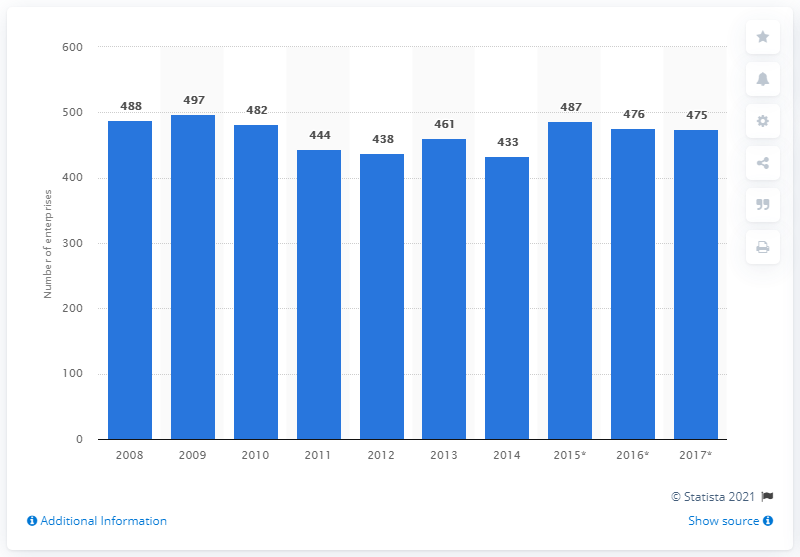Highlight a few significant elements in this photo. In 2017, there were 475 enterprises operating in the manufacturing of cocoa, chocolate, and sugar confectionery industry in Greece. 